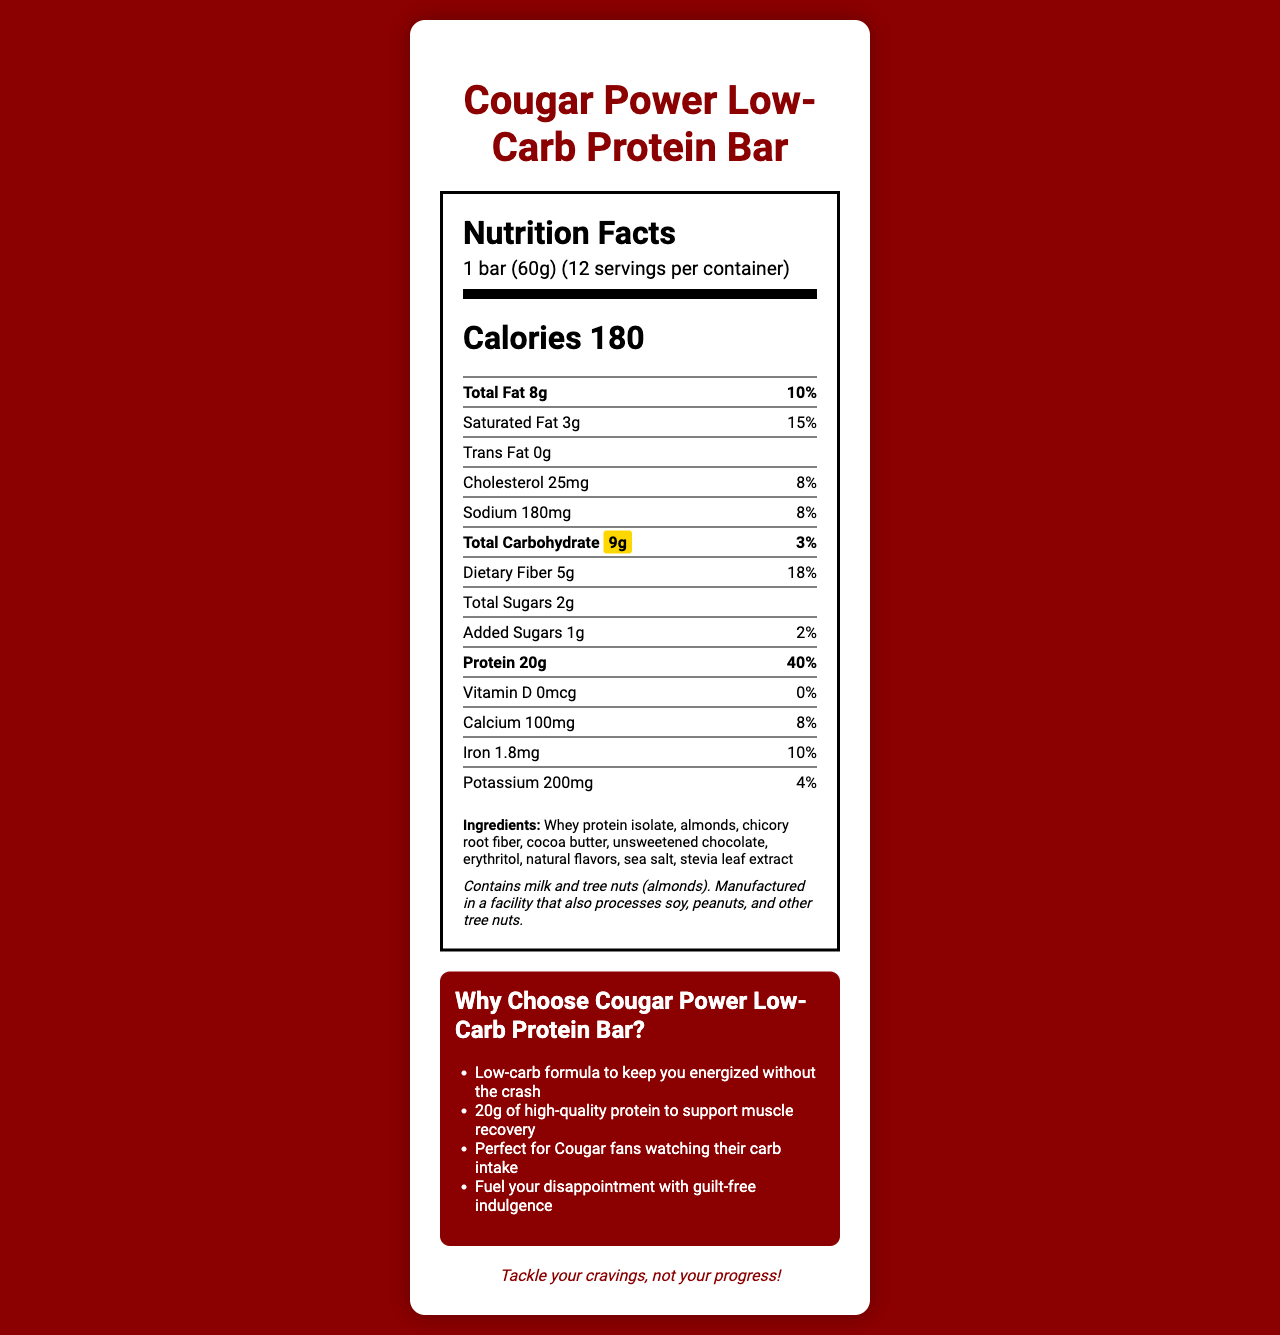what is the total carbohydrate content of the protein bar? The document highlights the total carbohydrate content as 9g.
Answer: 9g how many grams of protein are in one serving of the protein bar? The document states that there are 20g of protein per serving.
Answer: 20g what is the daily value percentage for dietary fiber? The nutritional label lists the daily value percentage for dietary fiber as 18%.
Answer: 18% how many calories are there per serving? The document mentions that each serving has 180 calories.
Answer: 180 what is the serving size of the protein bar? The document specifies the serving size as 1 bar weighing 60g.
Answer: 1 bar (60g) what is the daily value percentage for total carbohydrate? The document states that the daily value percentage for total carbohydrate is 3%.
Answer: 3% how many grams of total sugars are present in the protein bar? The nutritional label indicates that the protein bar contains 2g of total sugars.
Answer: 2g how much calcium is in one serving of the protein bar? The document lists the calcium content as 100mg per serving.
Answer: 100mg what ingredients are used in the protein bar? The ingredients are listed in the ingredients section on the document.
Answer: Whey protein isolate, almonds, chicory root fiber, cocoa butter, unsweetened chocolate, erythritol, natural flavors, sea salt, stevia leaf extract what allergens are mentioned in the protein bar's allergen information? The allergen information states that the protein bar contains milk and tree nuts (almonds).
Answer: Milk and tree nuts (almonds) what is the total fat content of the protein bar? The document shows that the total fat content is 8g per serving.
Answer: 8g how many servings are there per container? The document states that there are 12 servings per container.
Answer: 12 which nutrient has the highest daily value percentage? A. Total Fat B. Dietary Fiber C. Protein D. Sodium Protein has the highest daily value percentage at 40%.
Answer: C How much cholesterol does the protein bar contain? A. 20mg B. 25mg C. 30mg D. 35mg The nutritional label specifies that the protein bar contains 25mg of cholesterol.
Answer: B is there any trans fat in the protein bar? The document indicates that there is 0g of trans fat in the protein bar.
Answer: No summarize the main idea of the document. The document provides the nutritional breakdown, ingredient list, allergen information, and marketing claims for the Cougar Power Low-Carb Protein Bar, with a focus on its low carbohydrate content and high protein.
Answer: The document details the nutritional facts of the Cougar Power Low-Carb Protein Bar. It highlights its low carbohydrate content, its 20 grams of protein per serving, its 180 calories per serving, and key ingredients and allergens. Additionally, it emphasizes its benefits for muscle recovery and suitability for those looking to manage their carb intake. what is the vitamin C content in the protein bar? The document does not provide any information on the vitamin C content of the protein bar.
Answer: Cannot be determined 